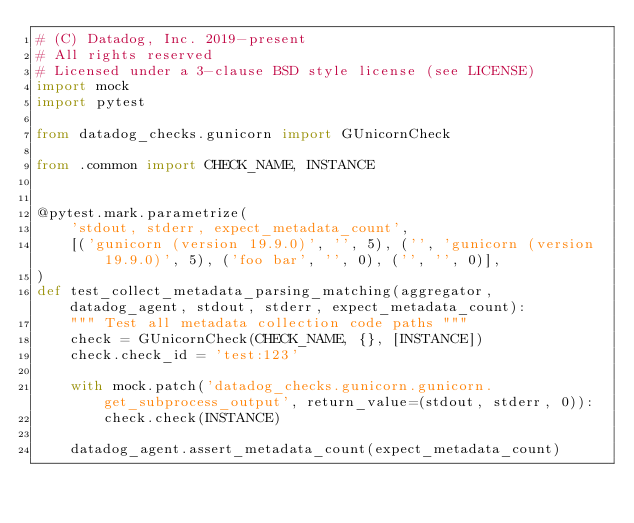Convert code to text. <code><loc_0><loc_0><loc_500><loc_500><_Python_># (C) Datadog, Inc. 2019-present
# All rights reserved
# Licensed under a 3-clause BSD style license (see LICENSE)
import mock
import pytest

from datadog_checks.gunicorn import GUnicornCheck

from .common import CHECK_NAME, INSTANCE


@pytest.mark.parametrize(
    'stdout, stderr, expect_metadata_count',
    [('gunicorn (version 19.9.0)', '', 5), ('', 'gunicorn (version 19.9.0)', 5), ('foo bar', '', 0), ('', '', 0)],
)
def test_collect_metadata_parsing_matching(aggregator, datadog_agent, stdout, stderr, expect_metadata_count):
    """ Test all metadata collection code paths """
    check = GUnicornCheck(CHECK_NAME, {}, [INSTANCE])
    check.check_id = 'test:123'

    with mock.patch('datadog_checks.gunicorn.gunicorn.get_subprocess_output', return_value=(stdout, stderr, 0)):
        check.check(INSTANCE)

    datadog_agent.assert_metadata_count(expect_metadata_count)
</code> 